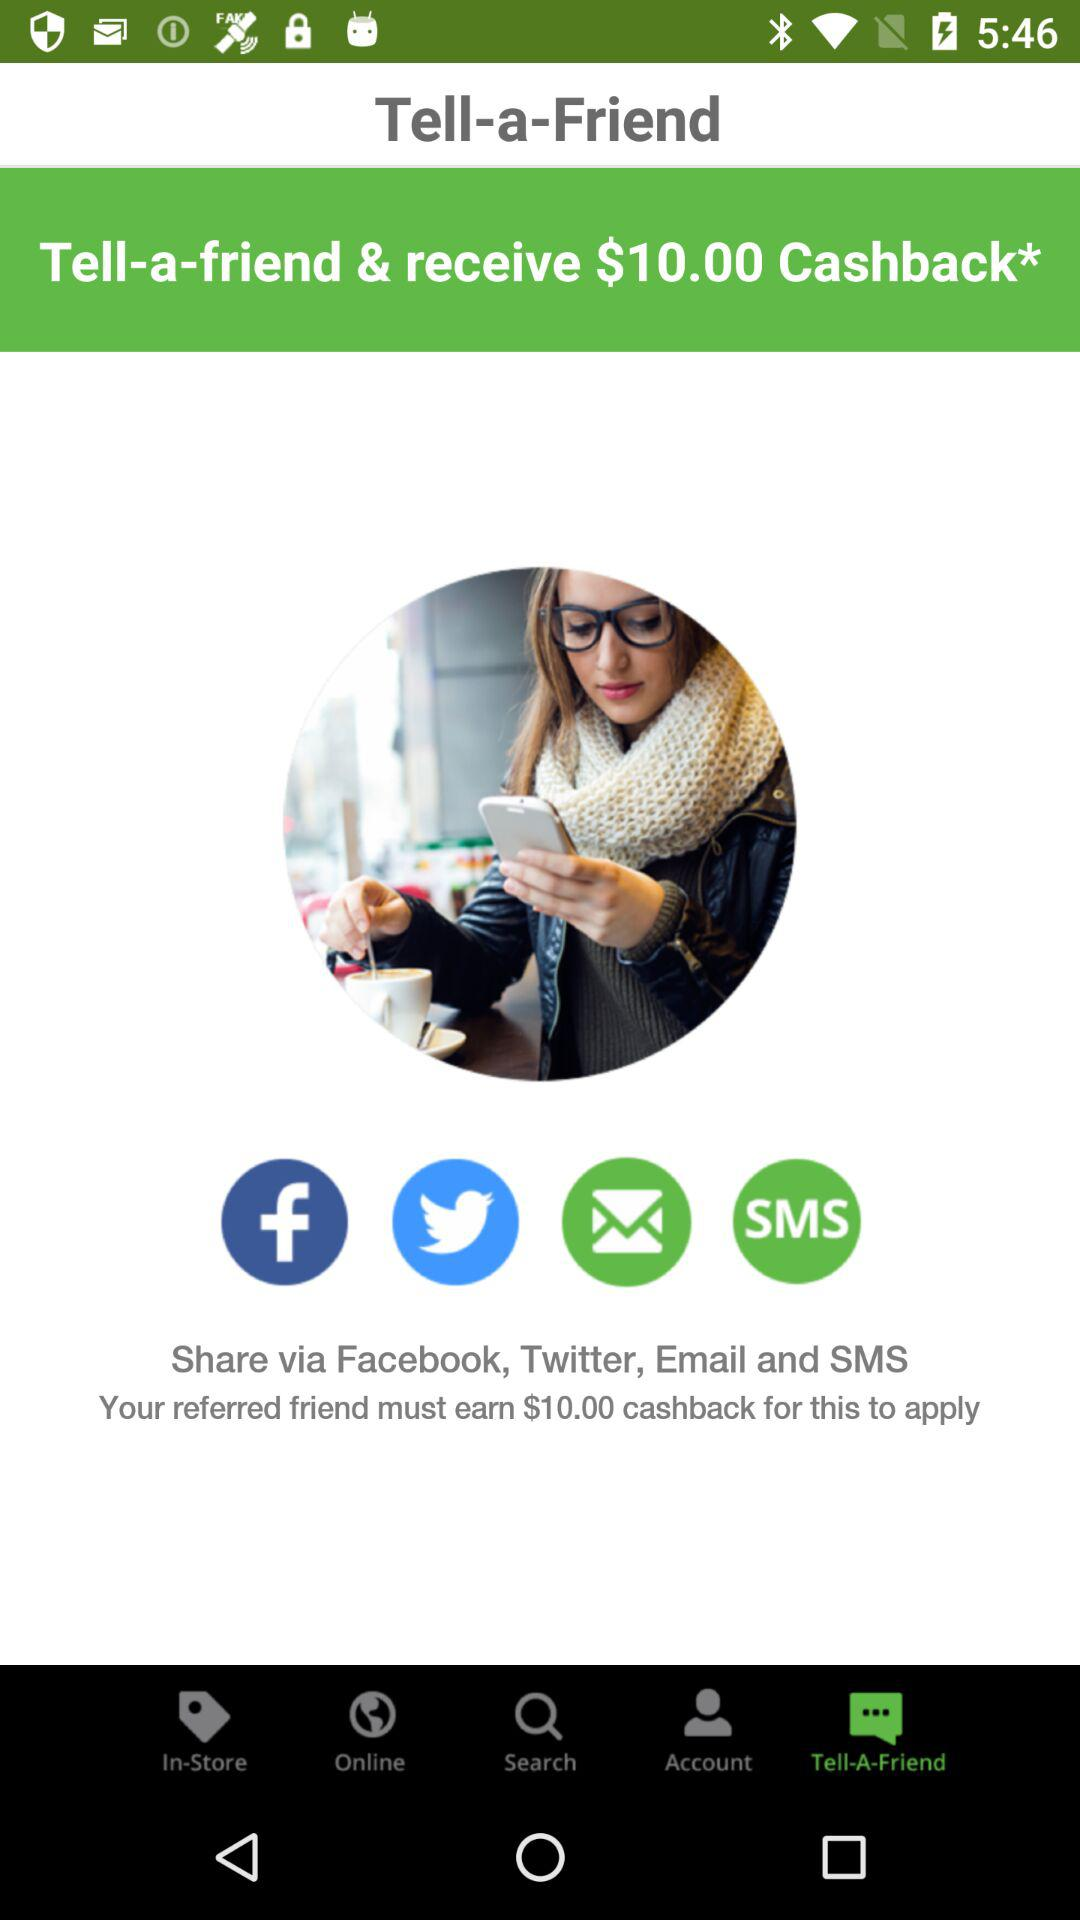How much cashback does the referred friend need to earn for the offer to apply?
Answer the question using a single word or phrase. $10.00 